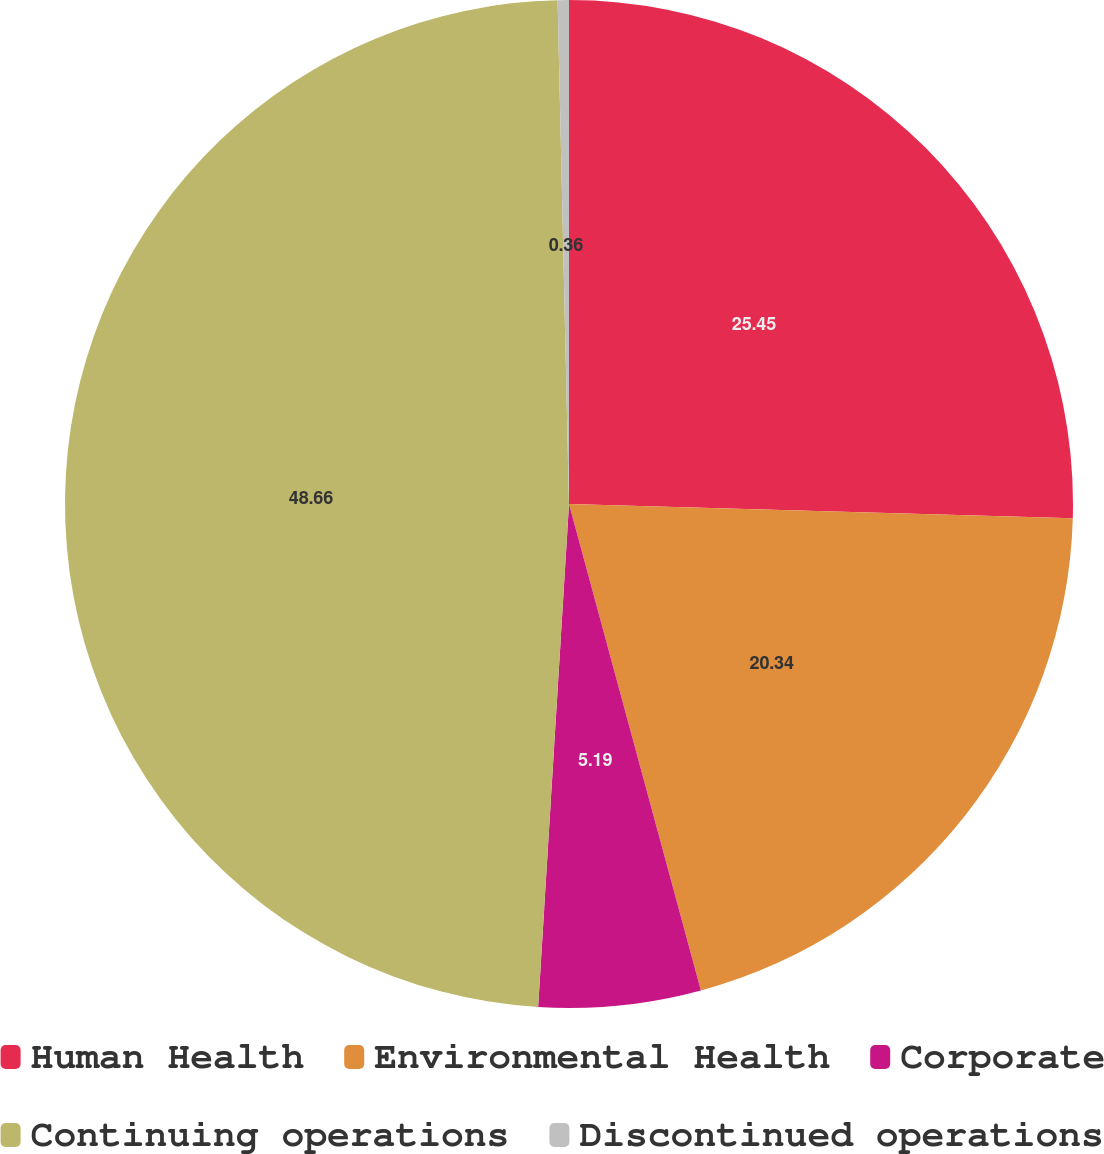Convert chart to OTSL. <chart><loc_0><loc_0><loc_500><loc_500><pie_chart><fcel>Human Health<fcel>Environmental Health<fcel>Corporate<fcel>Continuing operations<fcel>Discontinued operations<nl><fcel>25.45%<fcel>20.34%<fcel>5.19%<fcel>48.67%<fcel>0.36%<nl></chart> 